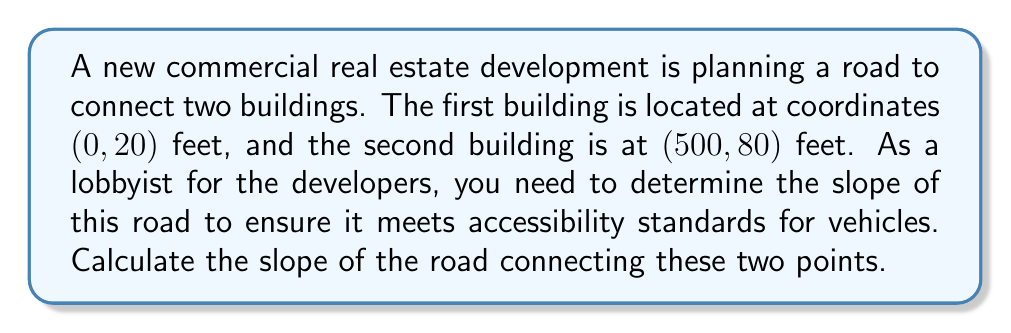Help me with this question. To calculate the slope of the road, we need to use the slope formula:

$$ \text{Slope} = \frac{\text{Rise}}{\text{Run}} = \frac{y_2 - y_1}{x_2 - x_1} $$

Where $(x_1, y_1)$ is the first point and $(x_2, y_2)$ is the second point.

Given:
- First point (Building 1): $(x_1, y_1) = (0, 20)$
- Second point (Building 2): $(x_2, y_2) = (500, 80)$

Let's substitute these values into the slope formula:

$$ \text{Slope} = \frac{80 - 20}{500 - 0} = \frac{60}{500} $$

Simplifying the fraction:

$$ \text{Slope} = \frac{60}{500} = \frac{3}{25} = 0.12 $$

This slope can also be expressed as a percentage:

$$ 0.12 \times 100\% = 12\% $$

The positive slope indicates that the road rises as it goes from Building 1 to Building 2.

[asy]
unitsize(0.01inch);
draw((0,0)--(500,60),Arrow);
draw((0,0)--(500,0),dashed);
draw((500,0)--(500,60),dashed);
label("500 ft", (250,-10));
label("60 ft", (510,30));
dot((0,0));
dot((500,60));
label("Building 1", (-10,-10));
label("Building 2", (510,70));
label("Slope = 3/25 = 12%", (250,40));
[/asy]
Answer: The slope of the road is $\frac{3}{25}$ or 0.12 or 12%. 